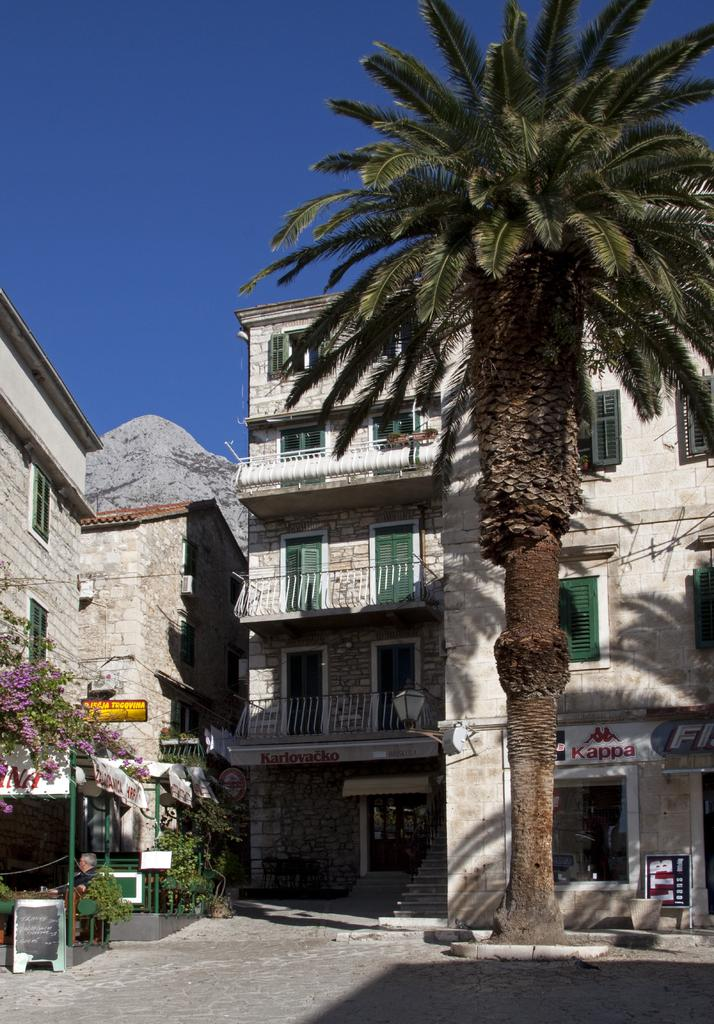Provide a one-sentence caption for the provided image. a building that has a red sign that says 'kappa' on it. 